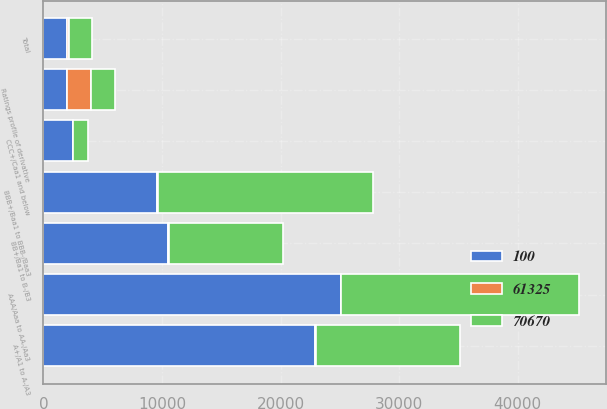Convert chart to OTSL. <chart><loc_0><loc_0><loc_500><loc_500><stacked_bar_chart><ecel><fcel>Ratings profile of derivative<fcel>AAA/Aaa to AA-/Aa3<fcel>A+/A1 to A-/A3<fcel>BBB+/Baa1 to BBB-/Baa3<fcel>BB+/Ba1 to B-/B3<fcel>CCC+/Caa1 and below<fcel>Total<nl><fcel>70670<fcel>2012<fcel>20040<fcel>12169<fcel>18197<fcel>9636<fcel>1283<fcel>2012<nl><fcel>61325<fcel>2012<fcel>33<fcel>20<fcel>29<fcel>16<fcel>2<fcel>100<nl><fcel>100<fcel>2011<fcel>25100<fcel>22942<fcel>9595<fcel>10545<fcel>2488<fcel>2012<nl></chart> 